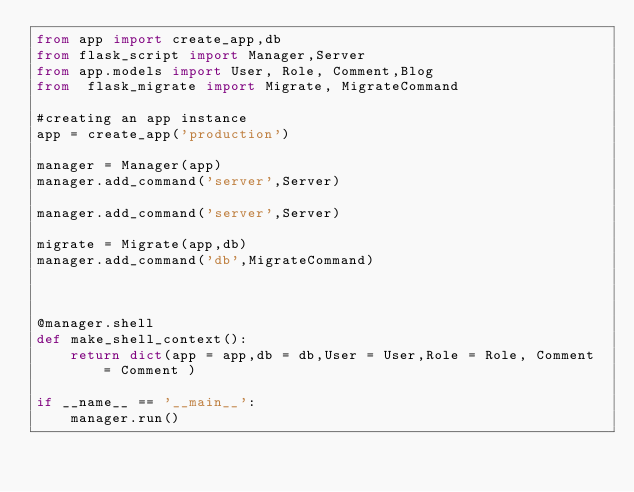<code> <loc_0><loc_0><loc_500><loc_500><_Python_>from app import create_app,db
from flask_script import Manager,Server
from app.models import User, Role, Comment,Blog
from  flask_migrate import Migrate, MigrateCommand

#creating an app instance
app = create_app('production')

manager = Manager(app)
manager.add_command('server',Server)

manager.add_command('server',Server)

migrate = Migrate(app,db)
manager.add_command('db',MigrateCommand)



@manager.shell
def make_shell_context():
    return dict(app = app,db = db,User = User,Role = Role, Comment = Comment )

if __name__ == '__main__':
    manager.run()
</code> 